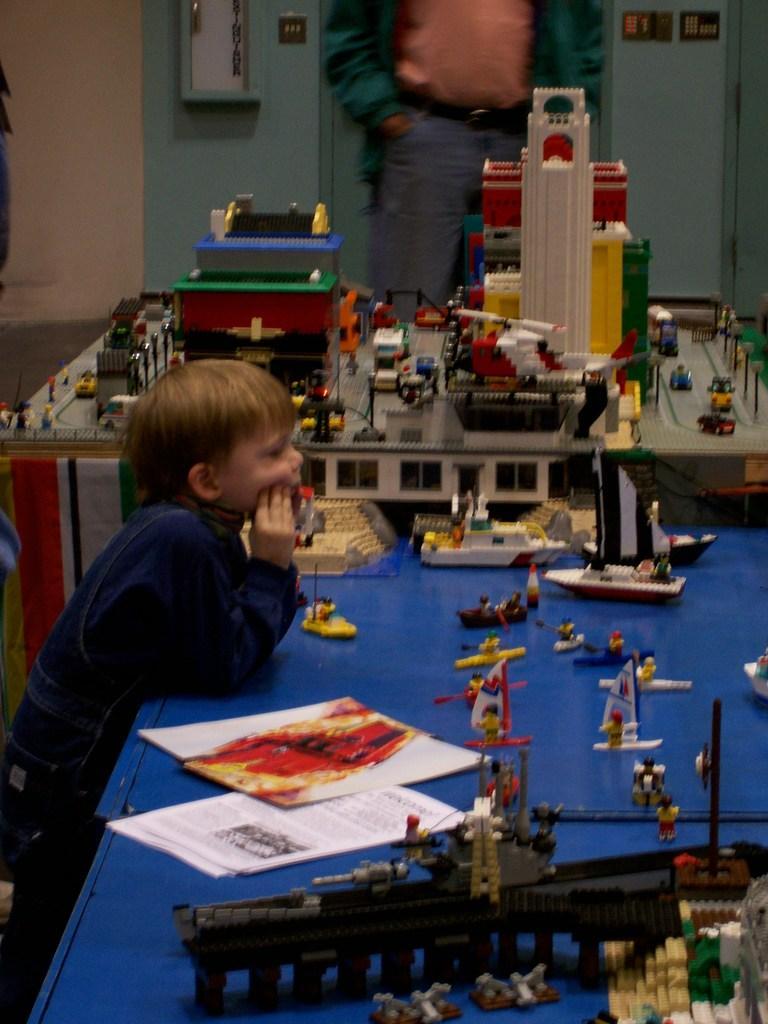Describe this image in one or two sentences. In this image we can see a child standing on the floor and tables are placed in front of him. On the tables we can see papers, crafts build with Legos and a man standing on the floor. 